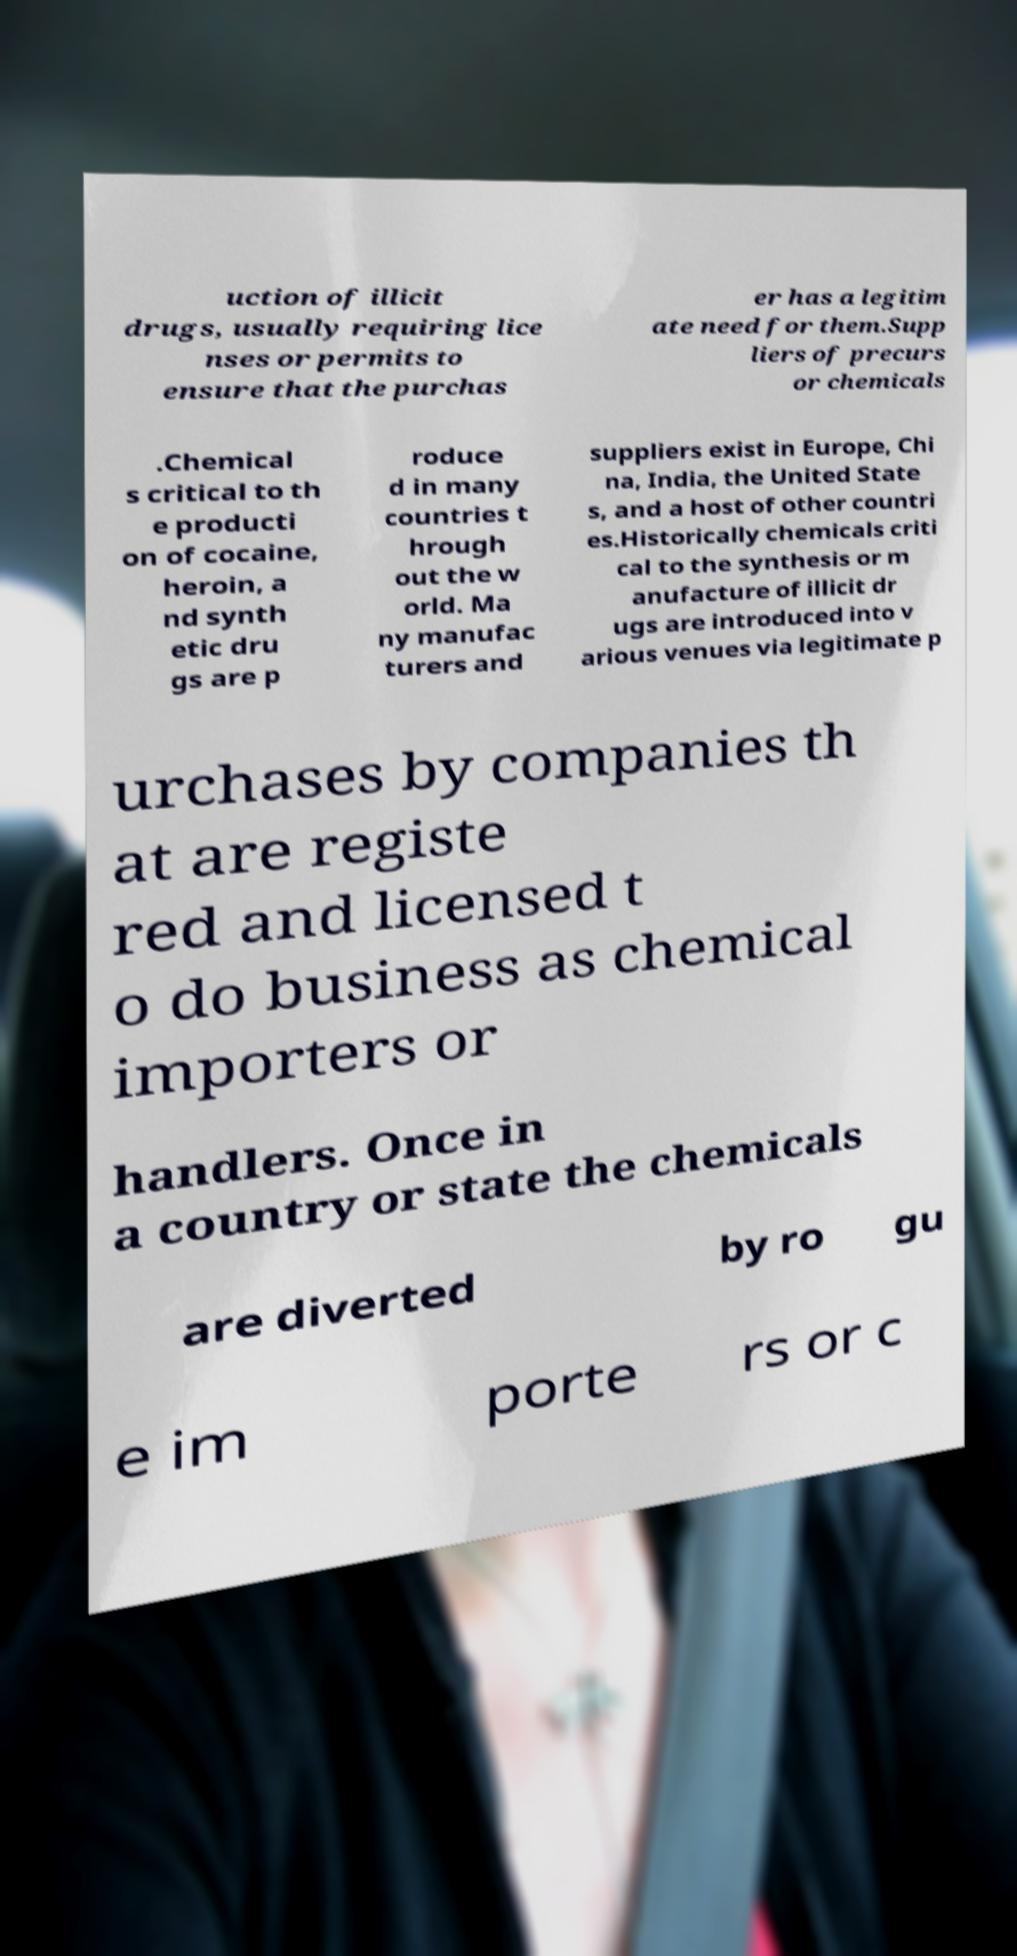I need the written content from this picture converted into text. Can you do that? uction of illicit drugs, usually requiring lice nses or permits to ensure that the purchas er has a legitim ate need for them.Supp liers of precurs or chemicals .Chemical s critical to th e producti on of cocaine, heroin, a nd synth etic dru gs are p roduce d in many countries t hrough out the w orld. Ma ny manufac turers and suppliers exist in Europe, Chi na, India, the United State s, and a host of other countri es.Historically chemicals criti cal to the synthesis or m anufacture of illicit dr ugs are introduced into v arious venues via legitimate p urchases by companies th at are registe red and licensed t o do business as chemical importers or handlers. Once in a country or state the chemicals are diverted by ro gu e im porte rs or c 